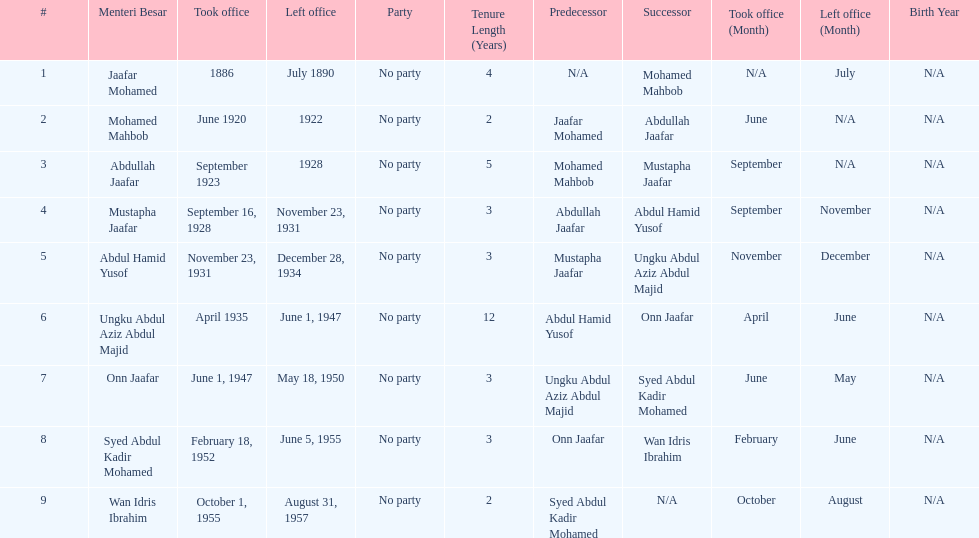Who is listed below onn jaafar? Syed Abdul Kadir Mohamed. 